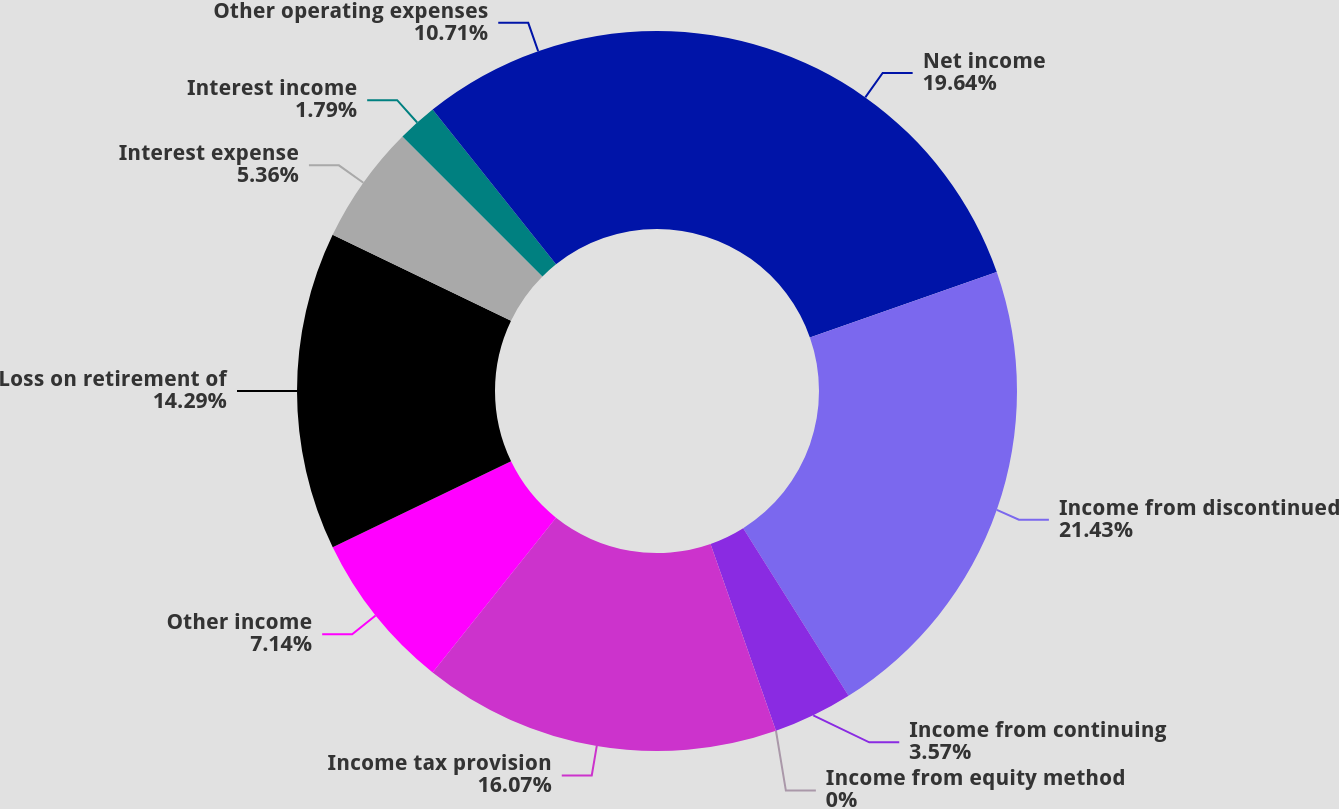<chart> <loc_0><loc_0><loc_500><loc_500><pie_chart><fcel>Net income<fcel>Income from discontinued<fcel>Income from continuing<fcel>Income from equity method<fcel>Income tax provision<fcel>Other income<fcel>Loss on retirement of<fcel>Interest expense<fcel>Interest income<fcel>Other operating expenses<nl><fcel>19.64%<fcel>21.43%<fcel>3.57%<fcel>0.0%<fcel>16.07%<fcel>7.14%<fcel>14.29%<fcel>5.36%<fcel>1.79%<fcel>10.71%<nl></chart> 